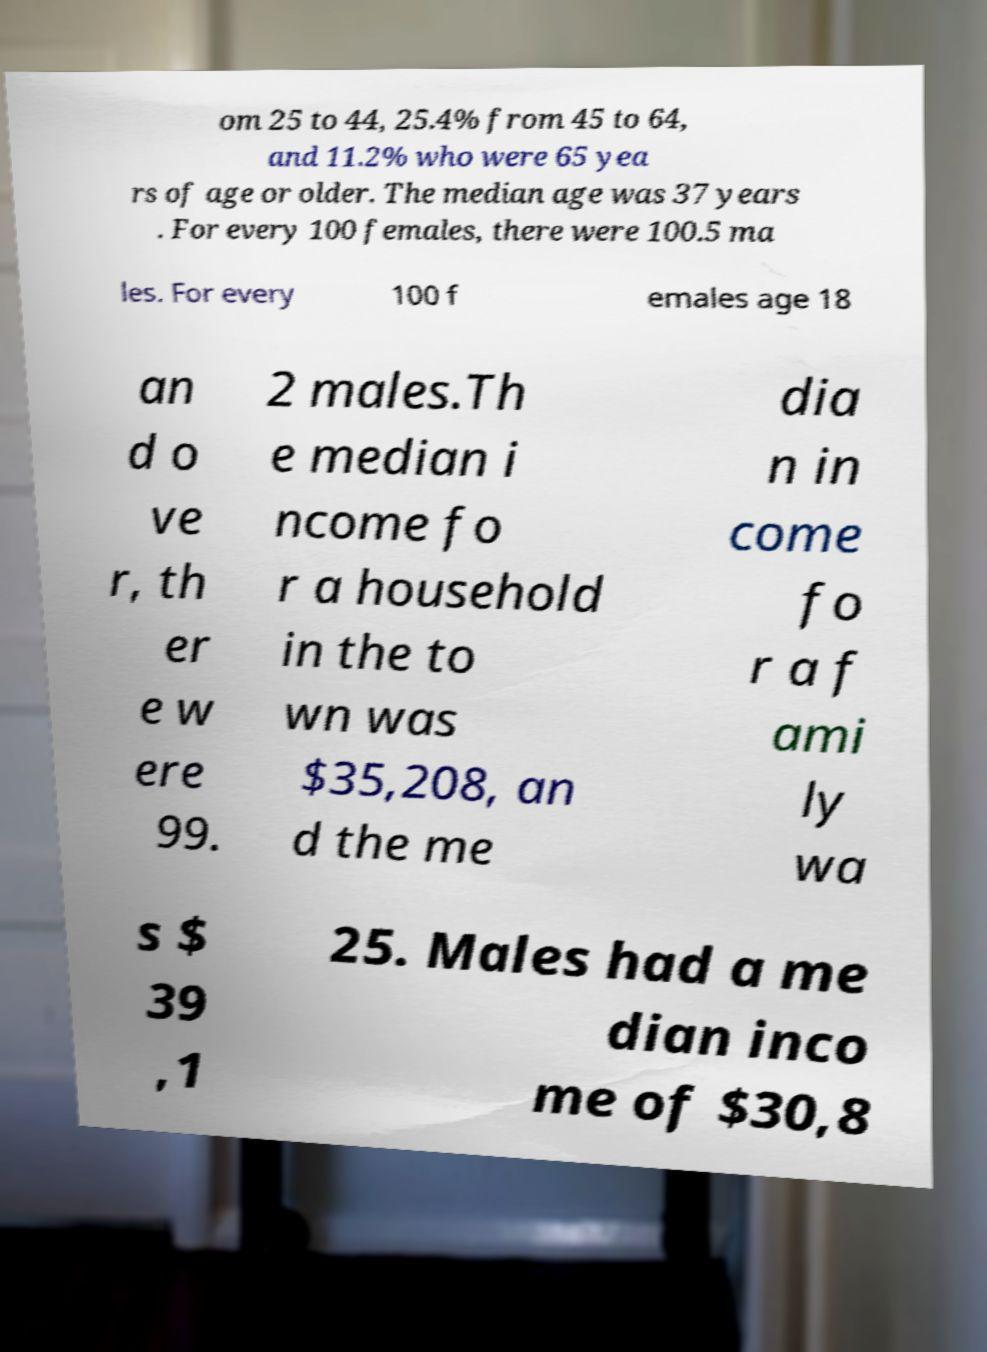Can you read and provide the text displayed in the image?This photo seems to have some interesting text. Can you extract and type it out for me? om 25 to 44, 25.4% from 45 to 64, and 11.2% who were 65 yea rs of age or older. The median age was 37 years . For every 100 females, there were 100.5 ma les. For every 100 f emales age 18 an d o ve r, th er e w ere 99. 2 males.Th e median i ncome fo r a household in the to wn was $35,208, an d the me dia n in come fo r a f ami ly wa s $ 39 ,1 25. Males had a me dian inco me of $30,8 